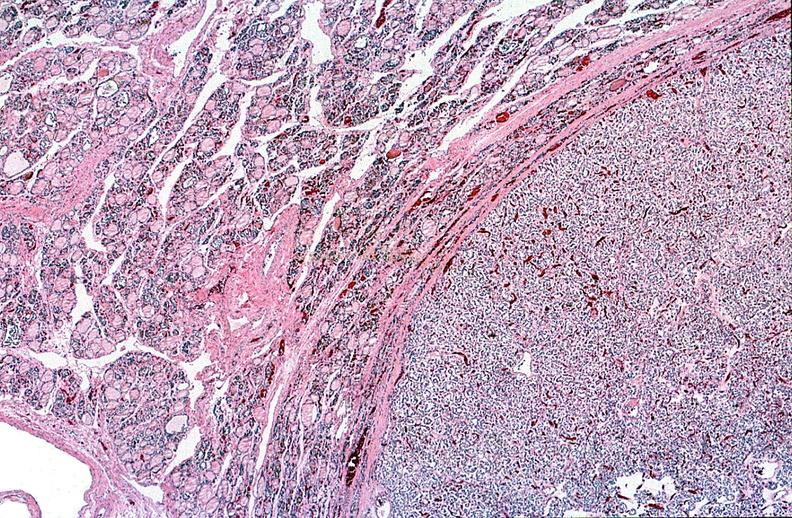where is this part in the figure?
Answer the question using a single word or phrase. Endocrine system 